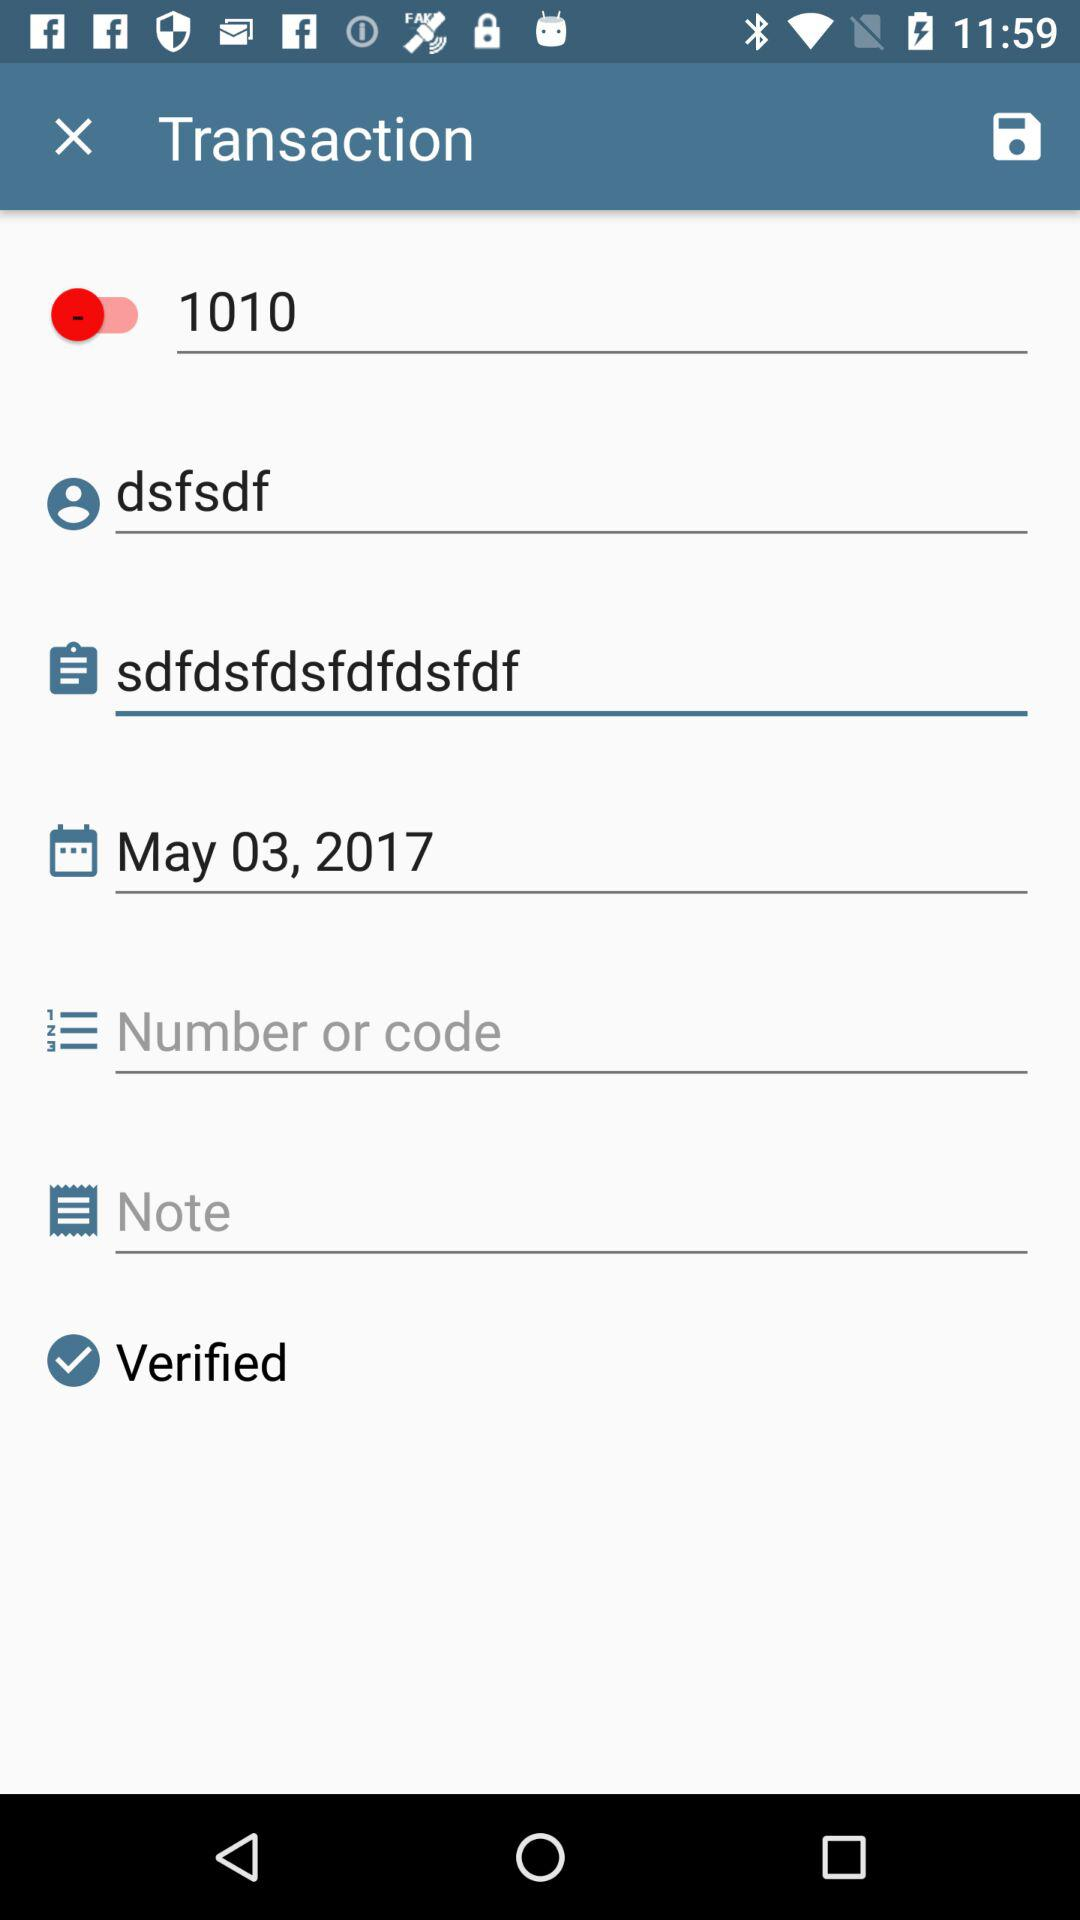What is the date? The date is May 03, 2017. 